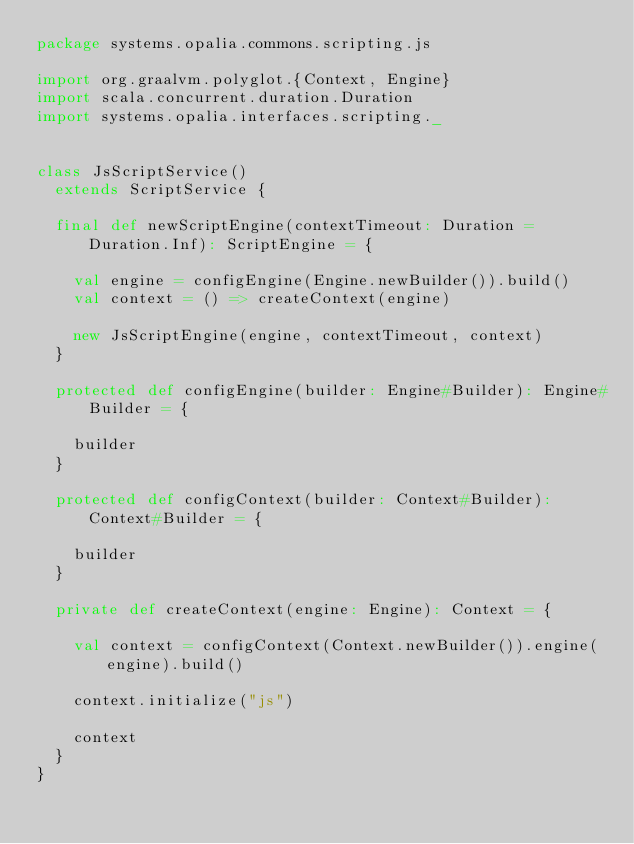Convert code to text. <code><loc_0><loc_0><loc_500><loc_500><_Scala_>package systems.opalia.commons.scripting.js

import org.graalvm.polyglot.{Context, Engine}
import scala.concurrent.duration.Duration
import systems.opalia.interfaces.scripting._


class JsScriptService()
  extends ScriptService {

  final def newScriptEngine(contextTimeout: Duration = Duration.Inf): ScriptEngine = {

    val engine = configEngine(Engine.newBuilder()).build()
    val context = () => createContext(engine)

    new JsScriptEngine(engine, contextTimeout, context)
  }

  protected def configEngine(builder: Engine#Builder): Engine#Builder = {

    builder
  }

  protected def configContext(builder: Context#Builder): Context#Builder = {

    builder
  }

  private def createContext(engine: Engine): Context = {

    val context = configContext(Context.newBuilder()).engine(engine).build()

    context.initialize("js")

    context
  }
}
</code> 